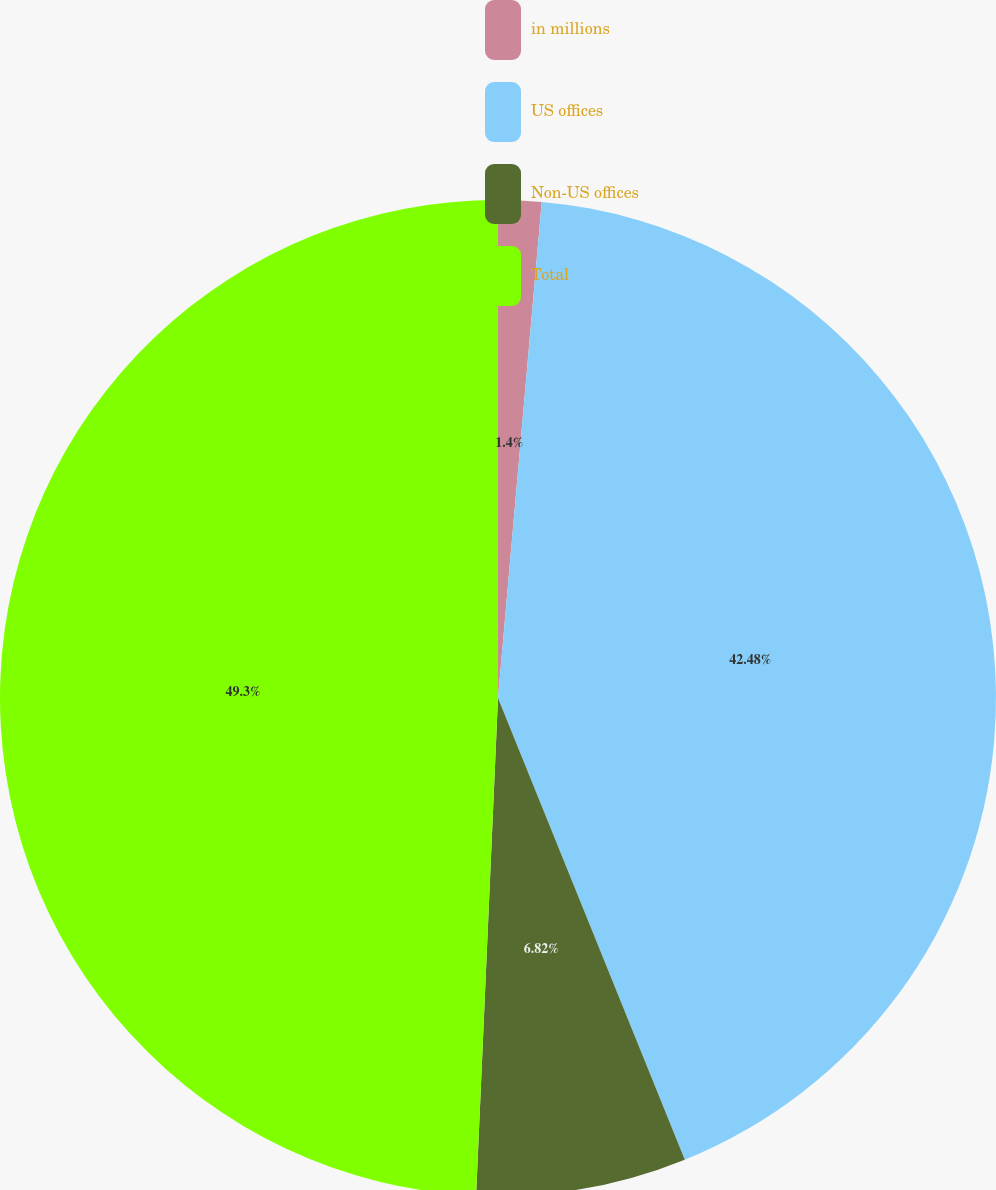<chart> <loc_0><loc_0><loc_500><loc_500><pie_chart><fcel>in millions<fcel>US offices<fcel>Non-US offices<fcel>Total<nl><fcel>1.4%<fcel>42.48%<fcel>6.82%<fcel>49.3%<nl></chart> 